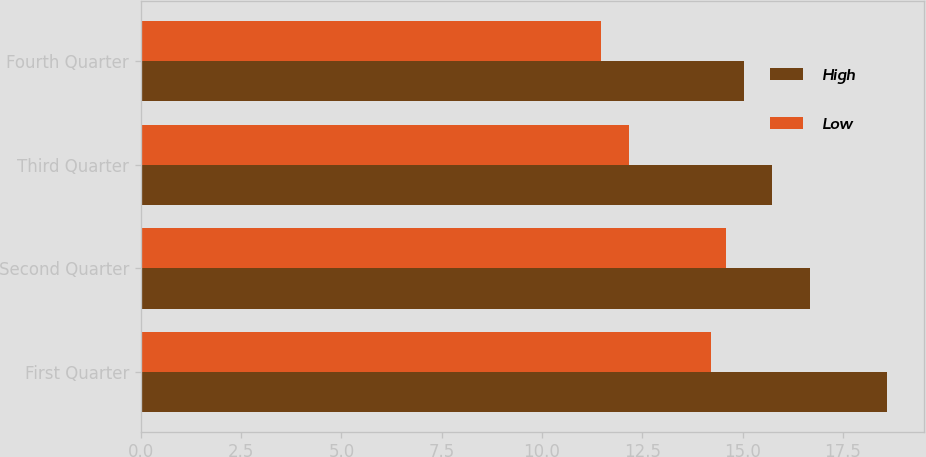<chart> <loc_0><loc_0><loc_500><loc_500><stacked_bar_chart><ecel><fcel>First Quarter<fcel>Second Quarter<fcel>Third Quarter<fcel>Fourth Quarter<nl><fcel>High<fcel>18.59<fcel>16.67<fcel>15.72<fcel>15.03<nl><fcel>Low<fcel>14.22<fcel>14.59<fcel>12.16<fcel>11.47<nl></chart> 